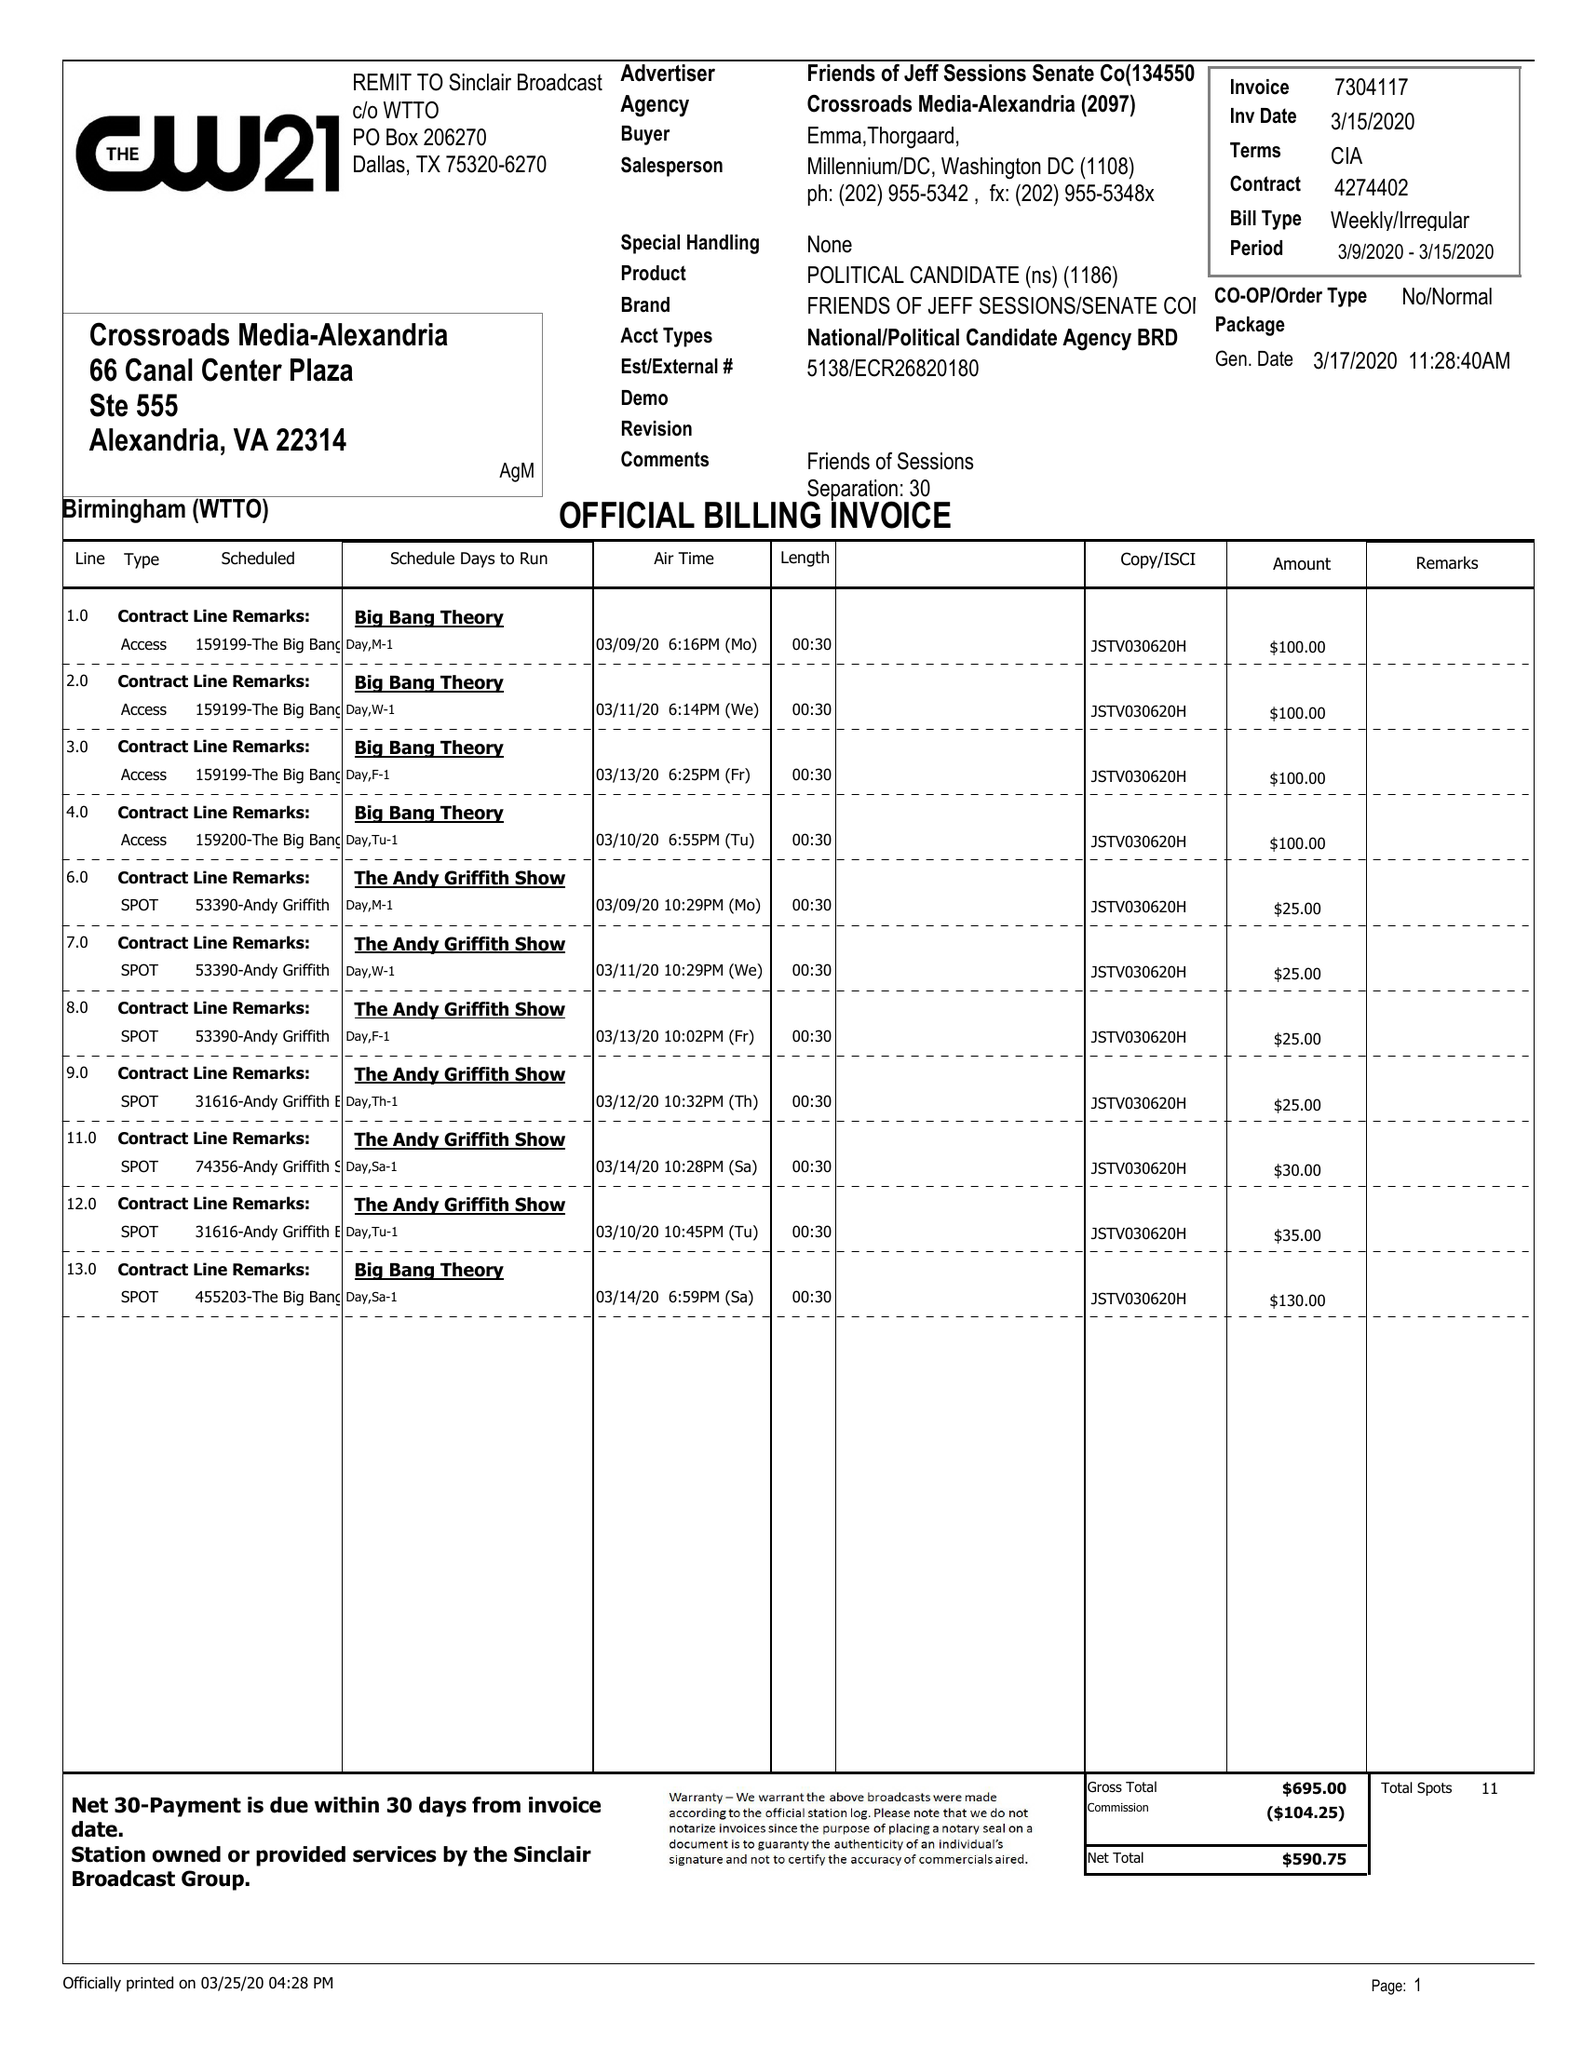What is the value for the advertiser?
Answer the question using a single word or phrase. FRIENDS OF JEFF SESSIONS SENATE CO 